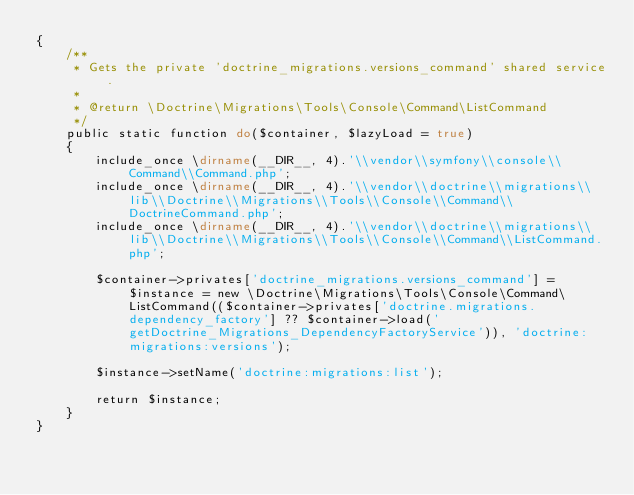Convert code to text. <code><loc_0><loc_0><loc_500><loc_500><_PHP_>{
    /**
     * Gets the private 'doctrine_migrations.versions_command' shared service.
     *
     * @return \Doctrine\Migrations\Tools\Console\Command\ListCommand
     */
    public static function do($container, $lazyLoad = true)
    {
        include_once \dirname(__DIR__, 4).'\\vendor\\symfony\\console\\Command\\Command.php';
        include_once \dirname(__DIR__, 4).'\\vendor\\doctrine\\migrations\\lib\\Doctrine\\Migrations\\Tools\\Console\\Command\\DoctrineCommand.php';
        include_once \dirname(__DIR__, 4).'\\vendor\\doctrine\\migrations\\lib\\Doctrine\\Migrations\\Tools\\Console\\Command\\ListCommand.php';

        $container->privates['doctrine_migrations.versions_command'] = $instance = new \Doctrine\Migrations\Tools\Console\Command\ListCommand(($container->privates['doctrine.migrations.dependency_factory'] ?? $container->load('getDoctrine_Migrations_DependencyFactoryService')), 'doctrine:migrations:versions');

        $instance->setName('doctrine:migrations:list');

        return $instance;
    }
}
</code> 